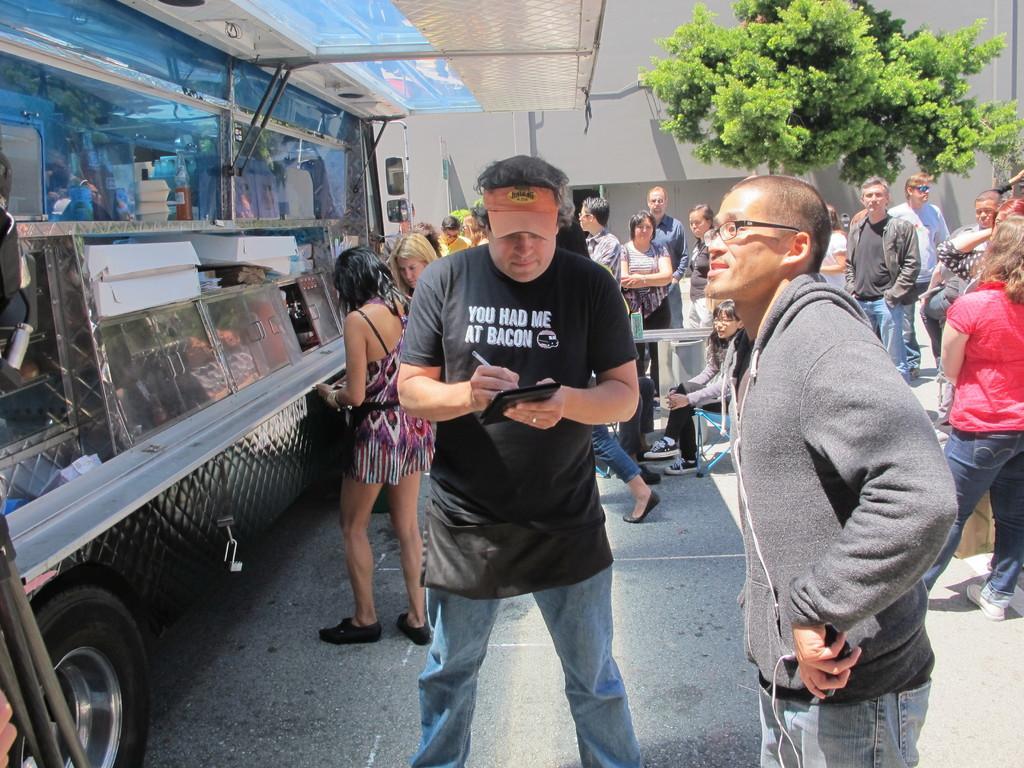Please provide a concise description of this image. Here we can see a food truck. Inside this food truck there are boxes, bottles and things. In-front of this food truck there are people. This man is holding a pen and an object. Far there is a tree. 